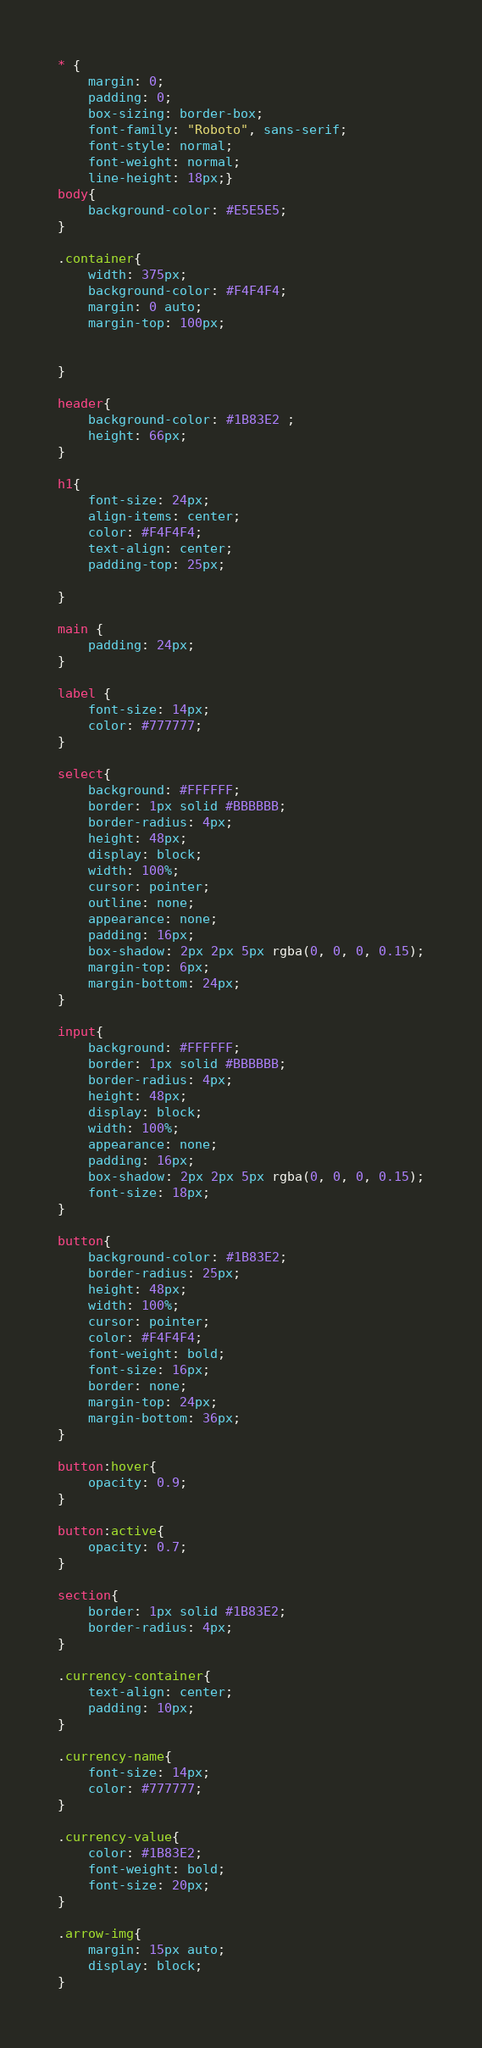Convert code to text. <code><loc_0><loc_0><loc_500><loc_500><_CSS_>* {
    margin: 0;
    padding: 0;
    box-sizing: border-box;
    font-family: "Roboto", sans-serif;
    font-style: normal;
    font-weight: normal;
    line-height: 18px;}
body{
    background-color: #E5E5E5;
}

.container{
    width: 375px;
    background-color: #F4F4F4;
    margin: 0 auto;
    margin-top: 100px;
    

}

header{
    background-color: #1B83E2 ;
    height: 66px;
}

h1{
    font-size: 24px;
    align-items: center;
    color: #F4F4F4;
    text-align: center;
    padding-top: 25px;

}

main {
    padding: 24px;
}

label {
    font-size: 14px;
    color: #777777;
}

select{
    background: #FFFFFF;
    border: 1px solid #BBBBBB;
    border-radius: 4px;
    height: 48px;
    display: block;
    width: 100%;
    cursor: pointer;
    outline: none;
    appearance: none;
    padding: 16px;
    box-shadow: 2px 2px 5px rgba(0, 0, 0, 0.15);
    margin-top: 6px;
    margin-bottom: 24px;
}

input{
    background: #FFFFFF;
    border: 1px solid #BBBBBB;
    border-radius: 4px;
    height: 48px;
    display: block;
    width: 100%;
    appearance: none;
    padding: 16px;
    box-shadow: 2px 2px 5px rgba(0, 0, 0, 0.15);
    font-size: 18px;
}

button{
    background-color: #1B83E2;
    border-radius: 25px;
    height: 48px;
    width: 100%;
    cursor: pointer;
    color: #F4F4F4;
    font-weight: bold;
    font-size: 16px;
    border: none;
    margin-top: 24px;
    margin-bottom: 36px;
}

button:hover{
    opacity: 0.9;
}

button:active{
    opacity: 0.7;
}

section{
    border: 1px solid #1B83E2;
    border-radius: 4px;
}

.currency-container{
    text-align: center;
    padding: 10px;
}

.currency-name{
    font-size: 14px;
    color: #777777;
}

.currency-value{
    color: #1B83E2;
    font-weight: bold;
    font-size: 20px;
}

.arrow-img{
    margin: 15px auto;
    display: block;
}</code> 